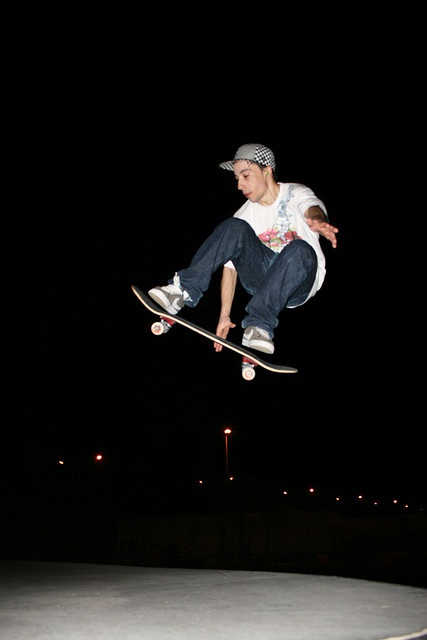Describe the objects in this image and their specific colors. I can see people in black, lightgray, and darkblue tones and skateboard in black, beige, gray, and darkgray tones in this image. 